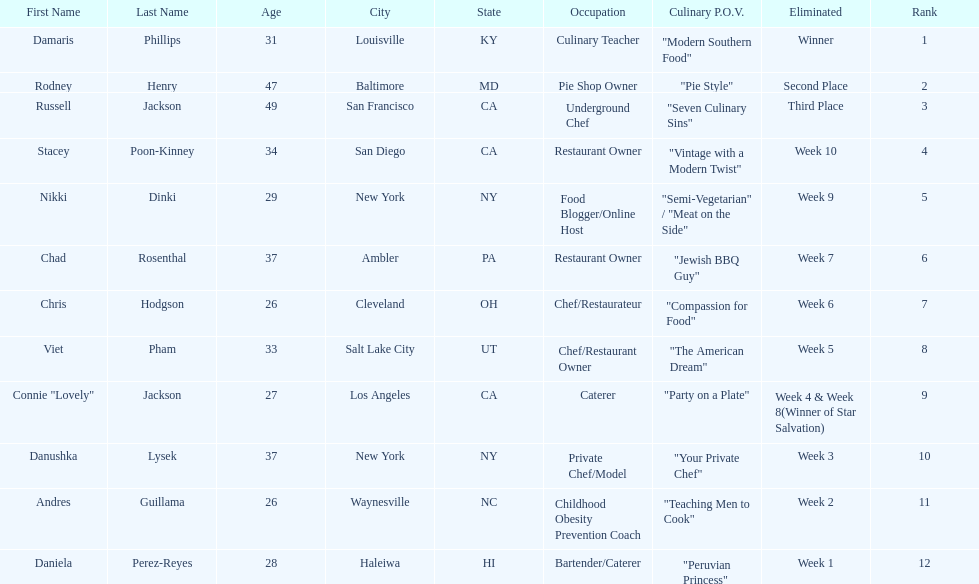Which contestant's culinary point of view had a longer description than "vintage with a modern twist"? Nikki Dinki. 